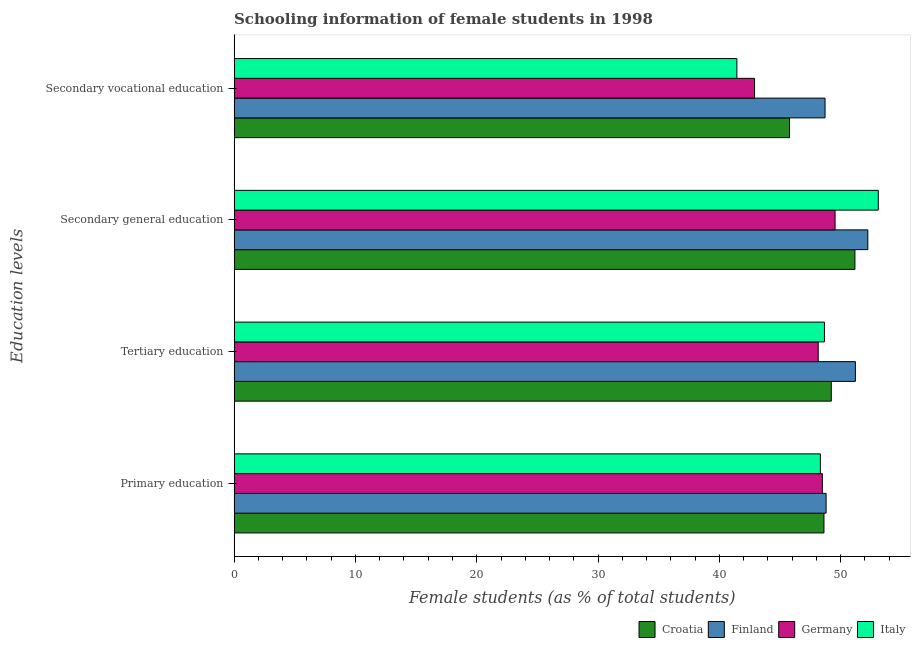How many groups of bars are there?
Ensure brevity in your answer.  4. Are the number of bars per tick equal to the number of legend labels?
Keep it short and to the point. Yes. Are the number of bars on each tick of the Y-axis equal?
Keep it short and to the point. Yes. How many bars are there on the 3rd tick from the top?
Your answer should be very brief. 4. What is the label of the 2nd group of bars from the top?
Offer a very short reply. Secondary general education. What is the percentage of female students in primary education in Croatia?
Provide a succinct answer. 48.62. Across all countries, what is the maximum percentage of female students in secondary education?
Provide a short and direct response. 53.1. Across all countries, what is the minimum percentage of female students in secondary education?
Give a very brief answer. 49.54. In which country was the percentage of female students in tertiary education maximum?
Keep it short and to the point. Finland. In which country was the percentage of female students in primary education minimum?
Provide a succinct answer. Italy. What is the total percentage of female students in tertiary education in the graph?
Provide a short and direct response. 197.25. What is the difference between the percentage of female students in secondary education in Italy and that in Croatia?
Give a very brief answer. 1.93. What is the difference between the percentage of female students in secondary vocational education in Italy and the percentage of female students in secondary education in Germany?
Make the answer very short. -8.09. What is the average percentage of female students in secondary education per country?
Your response must be concise. 51.51. What is the difference between the percentage of female students in primary education and percentage of female students in secondary vocational education in Finland?
Make the answer very short. 0.09. In how many countries, is the percentage of female students in tertiary education greater than 32 %?
Your response must be concise. 4. What is the ratio of the percentage of female students in secondary vocational education in Germany to that in Italy?
Your answer should be compact. 1.04. Is the percentage of female students in primary education in Italy less than that in Croatia?
Your answer should be compact. Yes. Is the difference between the percentage of female students in primary education in Croatia and Germany greater than the difference between the percentage of female students in tertiary education in Croatia and Germany?
Offer a terse response. No. What is the difference between the highest and the second highest percentage of female students in secondary education?
Provide a short and direct response. 0.86. What is the difference between the highest and the lowest percentage of female students in tertiary education?
Provide a succinct answer. 3.06. In how many countries, is the percentage of female students in secondary education greater than the average percentage of female students in secondary education taken over all countries?
Your answer should be compact. 2. Is the sum of the percentage of female students in secondary education in Finland and Germany greater than the maximum percentage of female students in tertiary education across all countries?
Ensure brevity in your answer.  Yes. What does the 3rd bar from the bottom in Secondary vocational education represents?
Ensure brevity in your answer.  Germany. Is it the case that in every country, the sum of the percentage of female students in primary education and percentage of female students in tertiary education is greater than the percentage of female students in secondary education?
Your answer should be very brief. Yes. What is the difference between two consecutive major ticks on the X-axis?
Offer a terse response. 10. Does the graph contain grids?
Give a very brief answer. No. How many legend labels are there?
Provide a short and direct response. 4. What is the title of the graph?
Ensure brevity in your answer.  Schooling information of female students in 1998. Does "Niger" appear as one of the legend labels in the graph?
Make the answer very short. No. What is the label or title of the X-axis?
Offer a terse response. Female students (as % of total students). What is the label or title of the Y-axis?
Keep it short and to the point. Education levels. What is the Female students (as % of total students) of Croatia in Primary education?
Offer a terse response. 48.62. What is the Female students (as % of total students) in Finland in Primary education?
Give a very brief answer. 48.8. What is the Female students (as % of total students) in Germany in Primary education?
Your answer should be very brief. 48.49. What is the Female students (as % of total students) in Italy in Primary education?
Your answer should be compact. 48.33. What is the Female students (as % of total students) in Croatia in Tertiary education?
Keep it short and to the point. 49.23. What is the Female students (as % of total students) in Finland in Tertiary education?
Your response must be concise. 51.21. What is the Female students (as % of total students) in Germany in Tertiary education?
Provide a short and direct response. 48.15. What is the Female students (as % of total students) in Italy in Tertiary education?
Give a very brief answer. 48.66. What is the Female students (as % of total students) of Croatia in Secondary general education?
Give a very brief answer. 51.17. What is the Female students (as % of total students) of Finland in Secondary general education?
Keep it short and to the point. 52.24. What is the Female students (as % of total students) of Germany in Secondary general education?
Ensure brevity in your answer.  49.54. What is the Female students (as % of total students) in Italy in Secondary general education?
Provide a succinct answer. 53.1. What is the Female students (as % of total students) in Croatia in Secondary vocational education?
Your answer should be very brief. 45.79. What is the Female students (as % of total students) in Finland in Secondary vocational education?
Provide a succinct answer. 48.71. What is the Female students (as % of total students) of Germany in Secondary vocational education?
Your response must be concise. 42.9. What is the Female students (as % of total students) of Italy in Secondary vocational education?
Keep it short and to the point. 41.44. Across all Education levels, what is the maximum Female students (as % of total students) of Croatia?
Offer a terse response. 51.17. Across all Education levels, what is the maximum Female students (as % of total students) in Finland?
Make the answer very short. 52.24. Across all Education levels, what is the maximum Female students (as % of total students) of Germany?
Offer a very short reply. 49.54. Across all Education levels, what is the maximum Female students (as % of total students) of Italy?
Ensure brevity in your answer.  53.1. Across all Education levels, what is the minimum Female students (as % of total students) in Croatia?
Provide a short and direct response. 45.79. Across all Education levels, what is the minimum Female students (as % of total students) of Finland?
Your answer should be compact. 48.71. Across all Education levels, what is the minimum Female students (as % of total students) of Germany?
Offer a very short reply. 42.9. Across all Education levels, what is the minimum Female students (as % of total students) in Italy?
Ensure brevity in your answer.  41.44. What is the total Female students (as % of total students) of Croatia in the graph?
Keep it short and to the point. 194.81. What is the total Female students (as % of total students) in Finland in the graph?
Keep it short and to the point. 200.96. What is the total Female students (as % of total students) of Germany in the graph?
Offer a terse response. 189.08. What is the total Female students (as % of total students) in Italy in the graph?
Provide a succinct answer. 191.54. What is the difference between the Female students (as % of total students) in Croatia in Primary education and that in Tertiary education?
Your response must be concise. -0.6. What is the difference between the Female students (as % of total students) in Finland in Primary education and that in Tertiary education?
Ensure brevity in your answer.  -2.41. What is the difference between the Female students (as % of total students) of Germany in Primary education and that in Tertiary education?
Provide a short and direct response. 0.34. What is the difference between the Female students (as % of total students) in Italy in Primary education and that in Tertiary education?
Provide a succinct answer. -0.34. What is the difference between the Female students (as % of total students) in Croatia in Primary education and that in Secondary general education?
Your answer should be very brief. -2.55. What is the difference between the Female students (as % of total students) of Finland in Primary education and that in Secondary general education?
Ensure brevity in your answer.  -3.44. What is the difference between the Female students (as % of total students) in Germany in Primary education and that in Secondary general education?
Offer a terse response. -1.05. What is the difference between the Female students (as % of total students) in Italy in Primary education and that in Secondary general education?
Provide a succinct answer. -4.77. What is the difference between the Female students (as % of total students) of Croatia in Primary education and that in Secondary vocational education?
Provide a succinct answer. 2.84. What is the difference between the Female students (as % of total students) in Finland in Primary education and that in Secondary vocational education?
Give a very brief answer. 0.09. What is the difference between the Female students (as % of total students) of Germany in Primary education and that in Secondary vocational education?
Give a very brief answer. 5.59. What is the difference between the Female students (as % of total students) of Italy in Primary education and that in Secondary vocational education?
Your answer should be very brief. 6.88. What is the difference between the Female students (as % of total students) of Croatia in Tertiary education and that in Secondary general education?
Provide a succinct answer. -1.95. What is the difference between the Female students (as % of total students) in Finland in Tertiary education and that in Secondary general education?
Your answer should be very brief. -1.02. What is the difference between the Female students (as % of total students) of Germany in Tertiary education and that in Secondary general education?
Give a very brief answer. -1.39. What is the difference between the Female students (as % of total students) of Italy in Tertiary education and that in Secondary general education?
Provide a short and direct response. -4.44. What is the difference between the Female students (as % of total students) in Croatia in Tertiary education and that in Secondary vocational education?
Make the answer very short. 3.44. What is the difference between the Female students (as % of total students) in Finland in Tertiary education and that in Secondary vocational education?
Provide a short and direct response. 2.5. What is the difference between the Female students (as % of total students) in Germany in Tertiary education and that in Secondary vocational education?
Your answer should be very brief. 5.25. What is the difference between the Female students (as % of total students) in Italy in Tertiary education and that in Secondary vocational education?
Keep it short and to the point. 7.22. What is the difference between the Female students (as % of total students) in Croatia in Secondary general education and that in Secondary vocational education?
Your answer should be very brief. 5.39. What is the difference between the Female students (as % of total students) of Finland in Secondary general education and that in Secondary vocational education?
Provide a succinct answer. 3.53. What is the difference between the Female students (as % of total students) in Germany in Secondary general education and that in Secondary vocational education?
Provide a succinct answer. 6.64. What is the difference between the Female students (as % of total students) in Italy in Secondary general education and that in Secondary vocational education?
Offer a very short reply. 11.66. What is the difference between the Female students (as % of total students) in Croatia in Primary education and the Female students (as % of total students) in Finland in Tertiary education?
Offer a very short reply. -2.59. What is the difference between the Female students (as % of total students) of Croatia in Primary education and the Female students (as % of total students) of Germany in Tertiary education?
Give a very brief answer. 0.47. What is the difference between the Female students (as % of total students) of Croatia in Primary education and the Female students (as % of total students) of Italy in Tertiary education?
Your answer should be very brief. -0.04. What is the difference between the Female students (as % of total students) of Finland in Primary education and the Female students (as % of total students) of Germany in Tertiary education?
Provide a succinct answer. 0.65. What is the difference between the Female students (as % of total students) in Finland in Primary education and the Female students (as % of total students) in Italy in Tertiary education?
Provide a short and direct response. 0.14. What is the difference between the Female students (as % of total students) of Germany in Primary education and the Female students (as % of total students) of Italy in Tertiary education?
Provide a succinct answer. -0.17. What is the difference between the Female students (as % of total students) in Croatia in Primary education and the Female students (as % of total students) in Finland in Secondary general education?
Offer a very short reply. -3.61. What is the difference between the Female students (as % of total students) of Croatia in Primary education and the Female students (as % of total students) of Germany in Secondary general education?
Give a very brief answer. -0.92. What is the difference between the Female students (as % of total students) of Croatia in Primary education and the Female students (as % of total students) of Italy in Secondary general education?
Offer a terse response. -4.48. What is the difference between the Female students (as % of total students) in Finland in Primary education and the Female students (as % of total students) in Germany in Secondary general education?
Your answer should be very brief. -0.74. What is the difference between the Female students (as % of total students) in Finland in Primary education and the Female students (as % of total students) in Italy in Secondary general education?
Provide a succinct answer. -4.3. What is the difference between the Female students (as % of total students) of Germany in Primary education and the Female students (as % of total students) of Italy in Secondary general education?
Your answer should be compact. -4.61. What is the difference between the Female students (as % of total students) of Croatia in Primary education and the Female students (as % of total students) of Finland in Secondary vocational education?
Your response must be concise. -0.09. What is the difference between the Female students (as % of total students) in Croatia in Primary education and the Female students (as % of total students) in Germany in Secondary vocational education?
Ensure brevity in your answer.  5.72. What is the difference between the Female students (as % of total students) of Croatia in Primary education and the Female students (as % of total students) of Italy in Secondary vocational education?
Provide a short and direct response. 7.18. What is the difference between the Female students (as % of total students) of Finland in Primary education and the Female students (as % of total students) of Germany in Secondary vocational education?
Your answer should be compact. 5.9. What is the difference between the Female students (as % of total students) of Finland in Primary education and the Female students (as % of total students) of Italy in Secondary vocational education?
Offer a terse response. 7.35. What is the difference between the Female students (as % of total students) in Germany in Primary education and the Female students (as % of total students) in Italy in Secondary vocational education?
Offer a terse response. 7.05. What is the difference between the Female students (as % of total students) of Croatia in Tertiary education and the Female students (as % of total students) of Finland in Secondary general education?
Offer a very short reply. -3.01. What is the difference between the Female students (as % of total students) of Croatia in Tertiary education and the Female students (as % of total students) of Germany in Secondary general education?
Provide a succinct answer. -0.31. What is the difference between the Female students (as % of total students) in Croatia in Tertiary education and the Female students (as % of total students) in Italy in Secondary general education?
Provide a succinct answer. -3.87. What is the difference between the Female students (as % of total students) of Finland in Tertiary education and the Female students (as % of total students) of Germany in Secondary general education?
Offer a very short reply. 1.67. What is the difference between the Female students (as % of total students) of Finland in Tertiary education and the Female students (as % of total students) of Italy in Secondary general education?
Your answer should be very brief. -1.89. What is the difference between the Female students (as % of total students) of Germany in Tertiary education and the Female students (as % of total students) of Italy in Secondary general education?
Provide a succinct answer. -4.95. What is the difference between the Female students (as % of total students) in Croatia in Tertiary education and the Female students (as % of total students) in Finland in Secondary vocational education?
Offer a terse response. 0.51. What is the difference between the Female students (as % of total students) of Croatia in Tertiary education and the Female students (as % of total students) of Germany in Secondary vocational education?
Your answer should be compact. 6.32. What is the difference between the Female students (as % of total students) in Croatia in Tertiary education and the Female students (as % of total students) in Italy in Secondary vocational education?
Keep it short and to the point. 7.78. What is the difference between the Female students (as % of total students) of Finland in Tertiary education and the Female students (as % of total students) of Germany in Secondary vocational education?
Give a very brief answer. 8.31. What is the difference between the Female students (as % of total students) of Finland in Tertiary education and the Female students (as % of total students) of Italy in Secondary vocational education?
Your answer should be compact. 9.77. What is the difference between the Female students (as % of total students) in Germany in Tertiary education and the Female students (as % of total students) in Italy in Secondary vocational education?
Make the answer very short. 6.71. What is the difference between the Female students (as % of total students) of Croatia in Secondary general education and the Female students (as % of total students) of Finland in Secondary vocational education?
Keep it short and to the point. 2.46. What is the difference between the Female students (as % of total students) of Croatia in Secondary general education and the Female students (as % of total students) of Germany in Secondary vocational education?
Provide a short and direct response. 8.27. What is the difference between the Female students (as % of total students) of Croatia in Secondary general education and the Female students (as % of total students) of Italy in Secondary vocational education?
Provide a short and direct response. 9.73. What is the difference between the Female students (as % of total students) in Finland in Secondary general education and the Female students (as % of total students) in Germany in Secondary vocational education?
Make the answer very short. 9.34. What is the difference between the Female students (as % of total students) of Finland in Secondary general education and the Female students (as % of total students) of Italy in Secondary vocational education?
Make the answer very short. 10.79. What is the difference between the Female students (as % of total students) in Germany in Secondary general education and the Female students (as % of total students) in Italy in Secondary vocational education?
Your response must be concise. 8.09. What is the average Female students (as % of total students) in Croatia per Education levels?
Give a very brief answer. 48.7. What is the average Female students (as % of total students) of Finland per Education levels?
Make the answer very short. 50.24. What is the average Female students (as % of total students) of Germany per Education levels?
Your answer should be very brief. 47.27. What is the average Female students (as % of total students) in Italy per Education levels?
Give a very brief answer. 47.88. What is the difference between the Female students (as % of total students) of Croatia and Female students (as % of total students) of Finland in Primary education?
Ensure brevity in your answer.  -0.18. What is the difference between the Female students (as % of total students) in Croatia and Female students (as % of total students) in Germany in Primary education?
Your answer should be very brief. 0.13. What is the difference between the Female students (as % of total students) of Croatia and Female students (as % of total students) of Italy in Primary education?
Your response must be concise. 0.3. What is the difference between the Female students (as % of total students) in Finland and Female students (as % of total students) in Germany in Primary education?
Offer a terse response. 0.31. What is the difference between the Female students (as % of total students) of Finland and Female students (as % of total students) of Italy in Primary education?
Provide a succinct answer. 0.47. What is the difference between the Female students (as % of total students) of Germany and Female students (as % of total students) of Italy in Primary education?
Provide a short and direct response. 0.16. What is the difference between the Female students (as % of total students) in Croatia and Female students (as % of total students) in Finland in Tertiary education?
Make the answer very short. -1.99. What is the difference between the Female students (as % of total students) of Croatia and Female students (as % of total students) of Germany in Tertiary education?
Provide a short and direct response. 1.08. What is the difference between the Female students (as % of total students) of Croatia and Female students (as % of total students) of Italy in Tertiary education?
Your answer should be very brief. 0.56. What is the difference between the Female students (as % of total students) in Finland and Female students (as % of total students) in Germany in Tertiary education?
Ensure brevity in your answer.  3.06. What is the difference between the Female students (as % of total students) of Finland and Female students (as % of total students) of Italy in Tertiary education?
Give a very brief answer. 2.55. What is the difference between the Female students (as % of total students) in Germany and Female students (as % of total students) in Italy in Tertiary education?
Offer a very short reply. -0.51. What is the difference between the Female students (as % of total students) of Croatia and Female students (as % of total students) of Finland in Secondary general education?
Your response must be concise. -1.06. What is the difference between the Female students (as % of total students) in Croatia and Female students (as % of total students) in Germany in Secondary general education?
Make the answer very short. 1.64. What is the difference between the Female students (as % of total students) of Croatia and Female students (as % of total students) of Italy in Secondary general education?
Offer a terse response. -1.93. What is the difference between the Female students (as % of total students) in Finland and Female students (as % of total students) in Germany in Secondary general education?
Ensure brevity in your answer.  2.7. What is the difference between the Female students (as % of total students) of Finland and Female students (as % of total students) of Italy in Secondary general education?
Give a very brief answer. -0.86. What is the difference between the Female students (as % of total students) in Germany and Female students (as % of total students) in Italy in Secondary general education?
Your response must be concise. -3.56. What is the difference between the Female students (as % of total students) of Croatia and Female students (as % of total students) of Finland in Secondary vocational education?
Keep it short and to the point. -2.93. What is the difference between the Female students (as % of total students) of Croatia and Female students (as % of total students) of Germany in Secondary vocational education?
Keep it short and to the point. 2.88. What is the difference between the Female students (as % of total students) in Croatia and Female students (as % of total students) in Italy in Secondary vocational education?
Give a very brief answer. 4.34. What is the difference between the Female students (as % of total students) in Finland and Female students (as % of total students) in Germany in Secondary vocational education?
Provide a succinct answer. 5.81. What is the difference between the Female students (as % of total students) in Finland and Female students (as % of total students) in Italy in Secondary vocational education?
Offer a very short reply. 7.27. What is the difference between the Female students (as % of total students) of Germany and Female students (as % of total students) of Italy in Secondary vocational education?
Your response must be concise. 1.46. What is the ratio of the Female students (as % of total students) of Croatia in Primary education to that in Tertiary education?
Make the answer very short. 0.99. What is the ratio of the Female students (as % of total students) of Finland in Primary education to that in Tertiary education?
Give a very brief answer. 0.95. What is the ratio of the Female students (as % of total students) of Italy in Primary education to that in Tertiary education?
Provide a short and direct response. 0.99. What is the ratio of the Female students (as % of total students) of Croatia in Primary education to that in Secondary general education?
Provide a short and direct response. 0.95. What is the ratio of the Female students (as % of total students) in Finland in Primary education to that in Secondary general education?
Provide a short and direct response. 0.93. What is the ratio of the Female students (as % of total students) of Germany in Primary education to that in Secondary general education?
Your response must be concise. 0.98. What is the ratio of the Female students (as % of total students) of Italy in Primary education to that in Secondary general education?
Make the answer very short. 0.91. What is the ratio of the Female students (as % of total students) of Croatia in Primary education to that in Secondary vocational education?
Your answer should be compact. 1.06. What is the ratio of the Female students (as % of total students) of Germany in Primary education to that in Secondary vocational education?
Your response must be concise. 1.13. What is the ratio of the Female students (as % of total students) in Italy in Primary education to that in Secondary vocational education?
Your answer should be very brief. 1.17. What is the ratio of the Female students (as % of total students) in Croatia in Tertiary education to that in Secondary general education?
Provide a succinct answer. 0.96. What is the ratio of the Female students (as % of total students) in Finland in Tertiary education to that in Secondary general education?
Your answer should be compact. 0.98. What is the ratio of the Female students (as % of total students) of Germany in Tertiary education to that in Secondary general education?
Make the answer very short. 0.97. What is the ratio of the Female students (as % of total students) of Italy in Tertiary education to that in Secondary general education?
Provide a short and direct response. 0.92. What is the ratio of the Female students (as % of total students) of Croatia in Tertiary education to that in Secondary vocational education?
Your response must be concise. 1.08. What is the ratio of the Female students (as % of total students) in Finland in Tertiary education to that in Secondary vocational education?
Ensure brevity in your answer.  1.05. What is the ratio of the Female students (as % of total students) in Germany in Tertiary education to that in Secondary vocational education?
Offer a very short reply. 1.12. What is the ratio of the Female students (as % of total students) of Italy in Tertiary education to that in Secondary vocational education?
Keep it short and to the point. 1.17. What is the ratio of the Female students (as % of total students) of Croatia in Secondary general education to that in Secondary vocational education?
Ensure brevity in your answer.  1.12. What is the ratio of the Female students (as % of total students) of Finland in Secondary general education to that in Secondary vocational education?
Offer a very short reply. 1.07. What is the ratio of the Female students (as % of total students) in Germany in Secondary general education to that in Secondary vocational education?
Ensure brevity in your answer.  1.15. What is the ratio of the Female students (as % of total students) in Italy in Secondary general education to that in Secondary vocational education?
Make the answer very short. 1.28. What is the difference between the highest and the second highest Female students (as % of total students) of Croatia?
Provide a short and direct response. 1.95. What is the difference between the highest and the second highest Female students (as % of total students) in Finland?
Your answer should be very brief. 1.02. What is the difference between the highest and the second highest Female students (as % of total students) of Germany?
Your answer should be compact. 1.05. What is the difference between the highest and the second highest Female students (as % of total students) in Italy?
Ensure brevity in your answer.  4.44. What is the difference between the highest and the lowest Female students (as % of total students) in Croatia?
Offer a very short reply. 5.39. What is the difference between the highest and the lowest Female students (as % of total students) of Finland?
Offer a terse response. 3.53. What is the difference between the highest and the lowest Female students (as % of total students) of Germany?
Your answer should be very brief. 6.64. What is the difference between the highest and the lowest Female students (as % of total students) of Italy?
Your answer should be very brief. 11.66. 